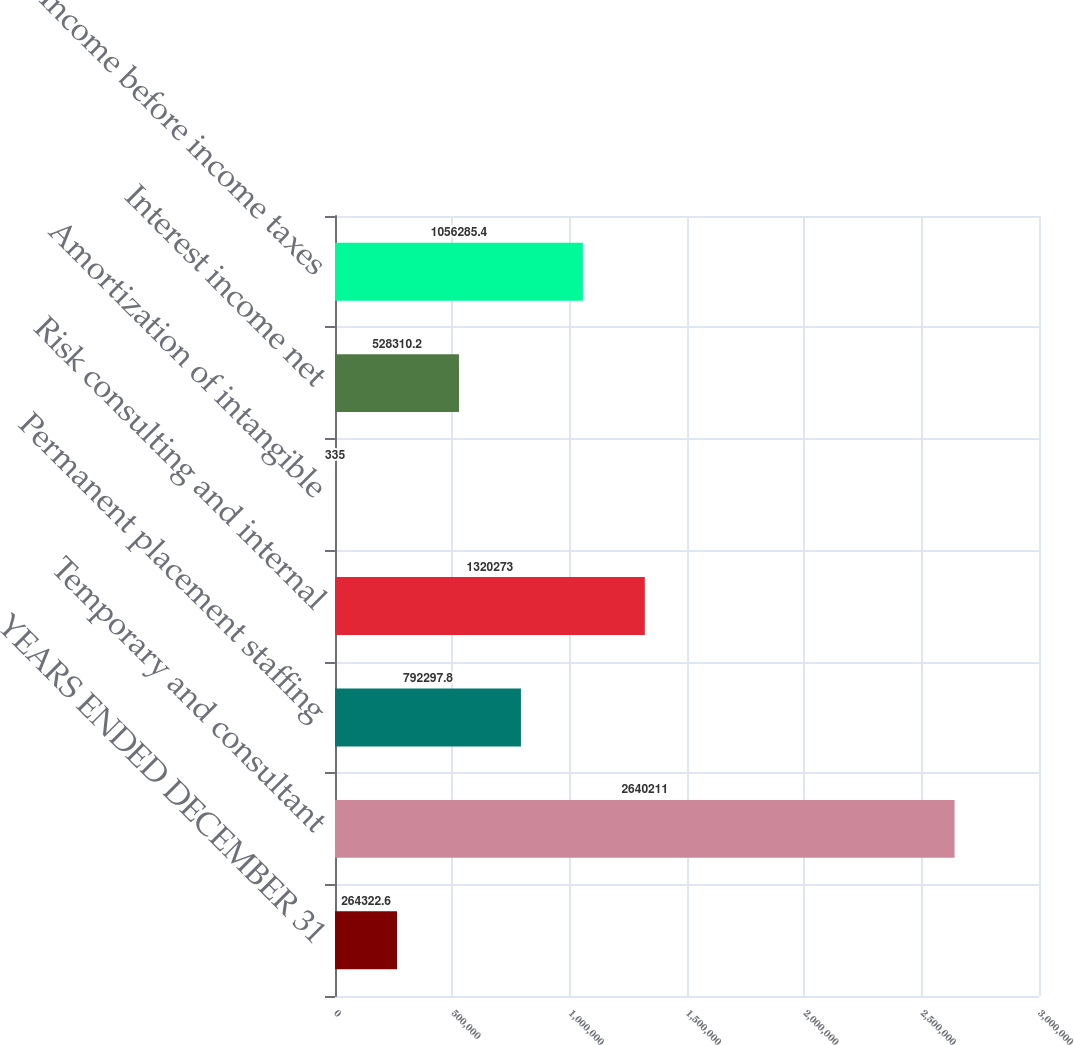Convert chart to OTSL. <chart><loc_0><loc_0><loc_500><loc_500><bar_chart><fcel>YEARS ENDED DECEMBER 31<fcel>Temporary and consultant<fcel>Permanent placement staffing<fcel>Risk consulting and internal<fcel>Amortization of intangible<fcel>Interest income net<fcel>Income before income taxes<nl><fcel>264323<fcel>2.64021e+06<fcel>792298<fcel>1.32027e+06<fcel>335<fcel>528310<fcel>1.05629e+06<nl></chart> 